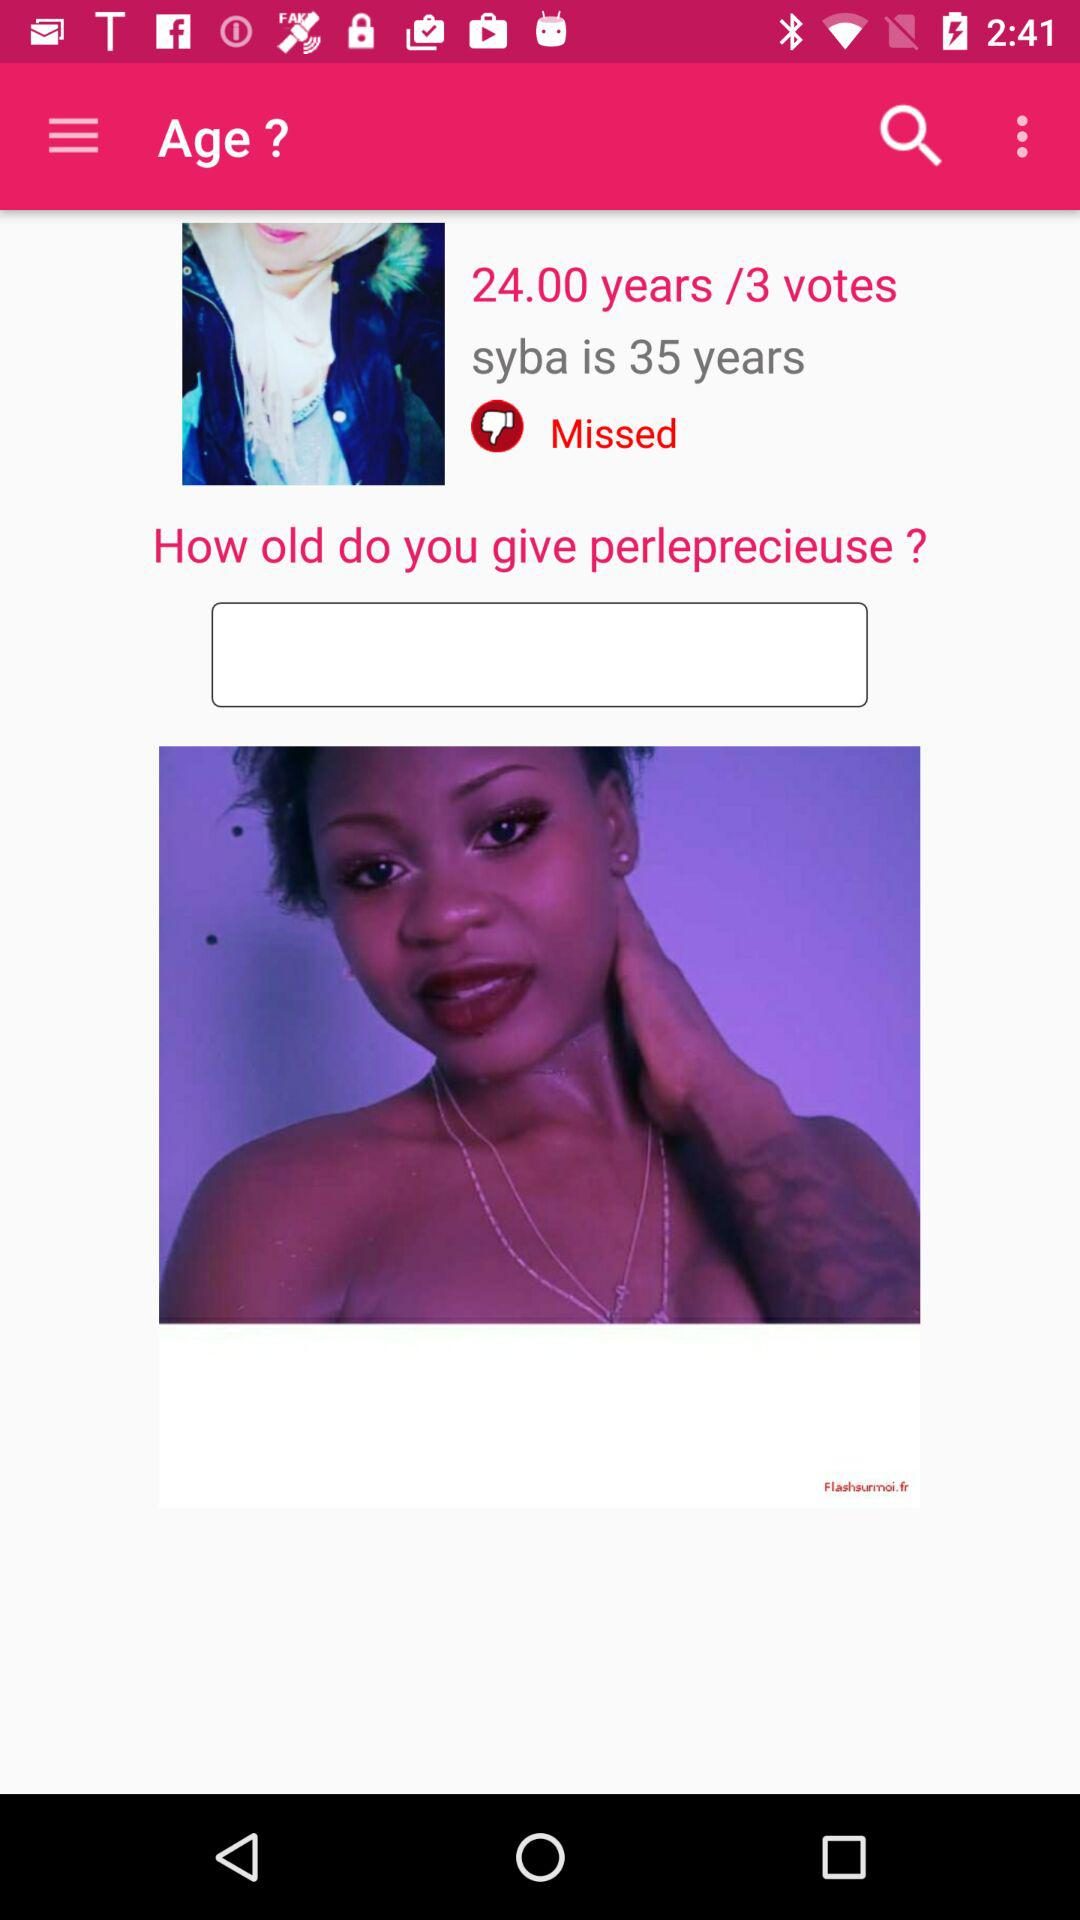How many votes are given to the person? There are 3 votes given to the person. 